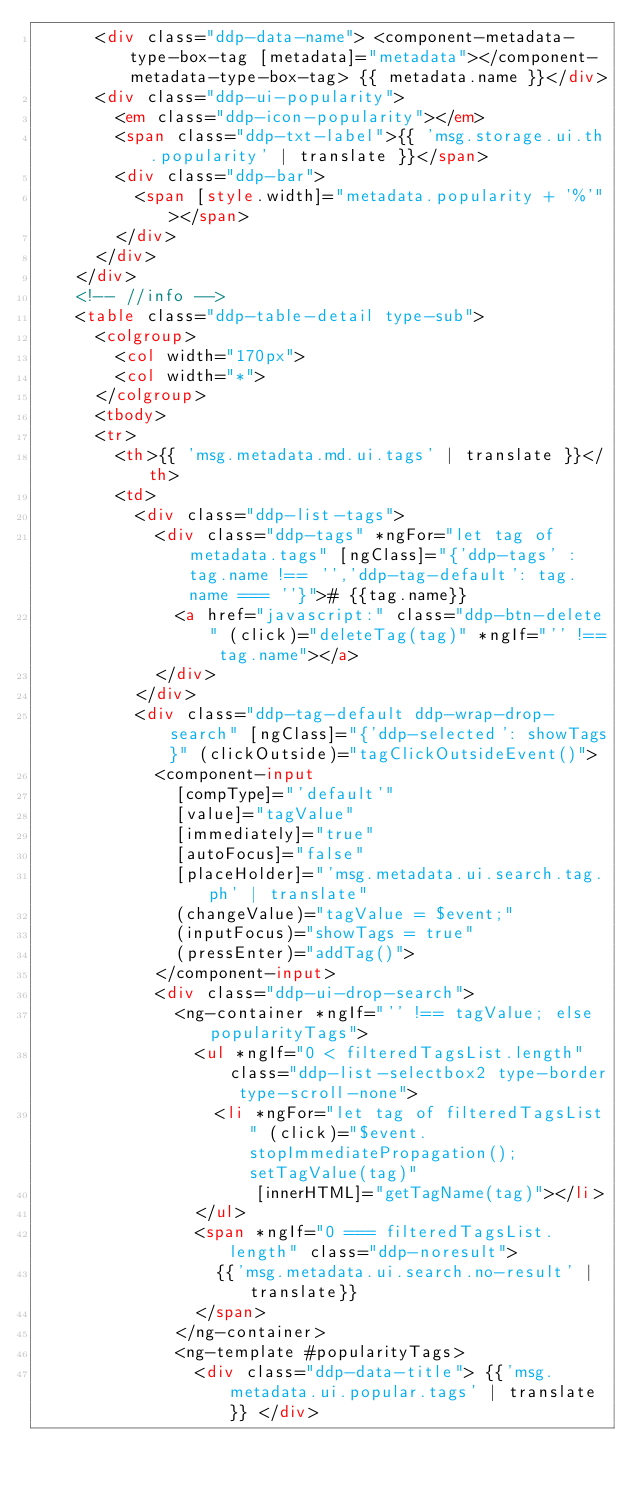<code> <loc_0><loc_0><loc_500><loc_500><_HTML_>      <div class="ddp-data-name"> <component-metadata-type-box-tag [metadata]="metadata"></component-metadata-type-box-tag> {{ metadata.name }}</div>
      <div class="ddp-ui-popularity">
        <em class="ddp-icon-popularity"></em>
        <span class="ddp-txt-label">{{ 'msg.storage.ui.th.popularity' | translate }}</span>
        <div class="ddp-bar">
          <span [style.width]="metadata.popularity + '%'"></span>
        </div>
      </div>
    </div>
    <!-- //info -->
    <table class="ddp-table-detail type-sub">
      <colgroup>
        <col width="170px">
        <col width="*">
      </colgroup>
      <tbody>
      <tr>
        <th>{{ 'msg.metadata.md.ui.tags' | translate }}</th>
        <td>
          <div class="ddp-list-tags">
            <div class="ddp-tags" *ngFor="let tag of metadata.tags" [ngClass]="{'ddp-tags' : tag.name !== '','ddp-tag-default': tag.name === ''}"># {{tag.name}}
              <a href="javascript:" class="ddp-btn-delete" (click)="deleteTag(tag)" *ngIf="'' !== tag.name"></a>
            </div>
          </div>
          <div class="ddp-tag-default ddp-wrap-drop-search" [ngClass]="{'ddp-selected': showTags}" (clickOutside)="tagClickOutsideEvent()">
            <component-input
              [compType]="'default'"
              [value]="tagValue"
              [immediately]="true"
              [autoFocus]="false"
              [placeHolder]="'msg.metadata.ui.search.tag.ph' | translate"
              (changeValue)="tagValue = $event;"
              (inputFocus)="showTags = true"
              (pressEnter)="addTag()">
            </component-input>
            <div class="ddp-ui-drop-search">
              <ng-container *ngIf="'' !== tagValue; else popularityTags">
                <ul *ngIf="0 < filteredTagsList.length" class="ddp-list-selectbox2 type-border type-scroll-none">
                  <li *ngFor="let tag of filteredTagsList" (click)="$event.stopImmediatePropagation();setTagValue(tag)"
                      [innerHTML]="getTagName(tag)"></li>
                </ul>
                <span *ngIf="0 === filteredTagsList.length" class="ddp-noresult">
                  {{'msg.metadata.ui.search.no-result' | translate}}
                </span>
              </ng-container>
              <ng-template #popularityTags>
                <div class="ddp-data-title"> {{'msg.metadata.ui.popular.tags' | translate}} </div></code> 